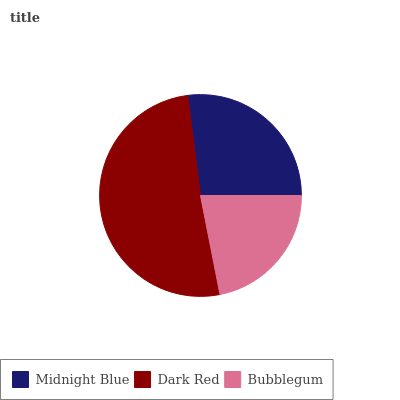Is Bubblegum the minimum?
Answer yes or no. Yes. Is Dark Red the maximum?
Answer yes or no. Yes. Is Dark Red the minimum?
Answer yes or no. No. Is Bubblegum the maximum?
Answer yes or no. No. Is Dark Red greater than Bubblegum?
Answer yes or no. Yes. Is Bubblegum less than Dark Red?
Answer yes or no. Yes. Is Bubblegum greater than Dark Red?
Answer yes or no. No. Is Dark Red less than Bubblegum?
Answer yes or no. No. Is Midnight Blue the high median?
Answer yes or no. Yes. Is Midnight Blue the low median?
Answer yes or no. Yes. Is Bubblegum the high median?
Answer yes or no. No. Is Bubblegum the low median?
Answer yes or no. No. 